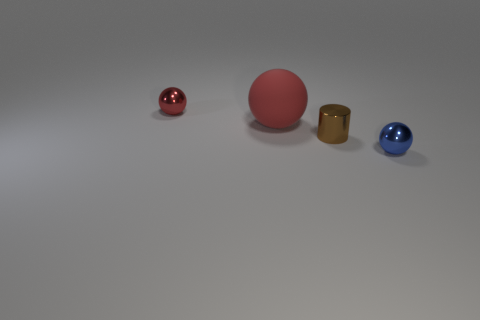Are there any other things that have the same size as the rubber ball?
Provide a succinct answer. No. Does the blue shiny object have the same size as the metal cylinder that is in front of the red metallic ball?
Your answer should be very brief. Yes. Are there any other things that are the same shape as the brown object?
Ensure brevity in your answer.  No. What number of brown metal cubes are there?
Make the answer very short. 0. What number of red things are metallic objects or large balls?
Offer a terse response. 2. Is the material of the red ball in front of the tiny red sphere the same as the tiny cylinder?
Your answer should be very brief. No. What number of other objects are there of the same material as the tiny blue object?
Ensure brevity in your answer.  2. What material is the small brown object?
Your response must be concise. Metal. How big is the matte thing that is left of the tiny metallic cylinder?
Your response must be concise. Large. There is a tiny sphere that is behind the blue metallic ball; what number of large red spheres are on the left side of it?
Your response must be concise. 0. 